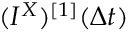<formula> <loc_0><loc_0><loc_500><loc_500>( I ^ { X } ) ^ { [ 1 ] } ( \Delta t )</formula> 